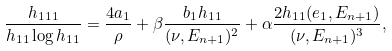<formula> <loc_0><loc_0><loc_500><loc_500>\frac { h _ { 1 1 1 } } { h _ { 1 1 } \log h _ { 1 1 } } = \frac { 4 a _ { 1 } } { \rho } + \beta \frac { b _ { 1 } h _ { 1 1 } } { ( \nu , E _ { n + 1 } ) ^ { 2 } } + \alpha \frac { 2 h _ { 1 1 } ( e _ { 1 } , E _ { n + 1 } ) } { ( \nu , E _ { n + 1 } ) ^ { 3 } } ,</formula> 